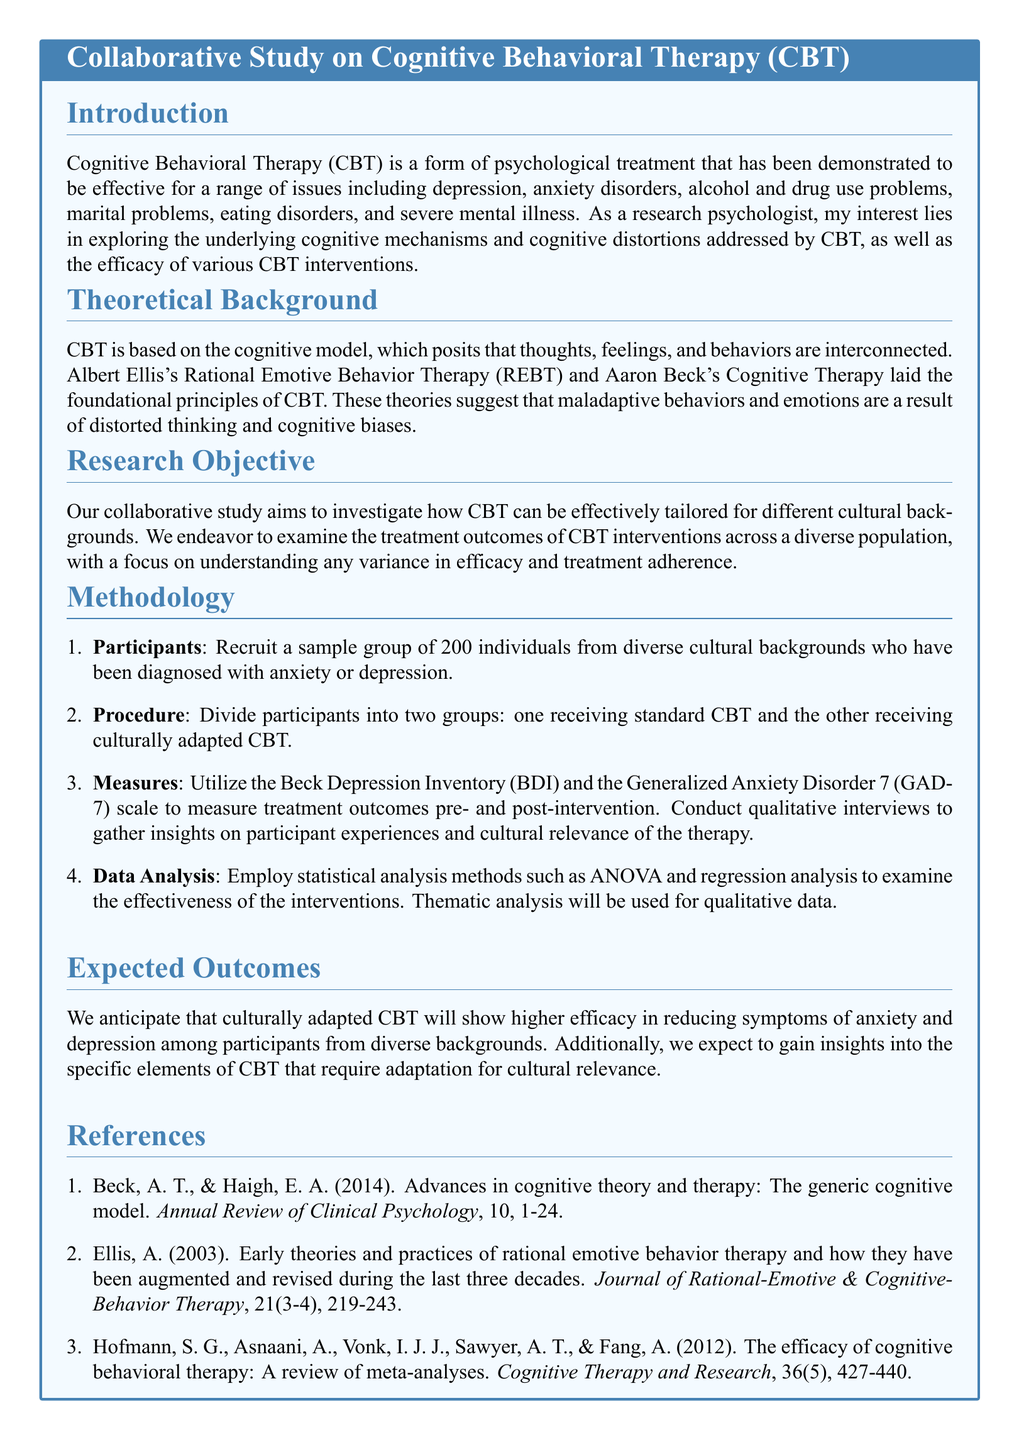What is CBT? CBT is defined in the introduction as a form of psychological treatment that is effective for various issues.
Answer: a form of psychological treatment Who developed Cognitive Therapy? The document mentions Aaron Beck as one of the developers of the foundational principles of CBT.
Answer: Aaron Beck What is the sample size for the study? The methodology section states that the sample group will consist of 200 individuals.
Answer: 200 individuals Which scale is used to measure treatment outcomes? The methodology specifies the use of the Beck Depression Inventory and the Generalized Anxiety Disorder 7 scale.
Answer: Beck Depression Inventory and GAD-7 scale What is the expected outcome of culturally adapted CBT? The document anticipates that culturally adapted CBT will show higher efficacy in reducing symptoms of anxiety and depression.
Answer: higher efficacy What analysis methods will be employed for data analysis? The methodology section outlines the use of statistical analysis methods such as ANOVA and regression analysis, along with thematic analysis for qualitative data.
Answer: ANOVA and regression analysis What is a primary focus of the research objective? The research objective primarily focuses on how CBT can be effectively tailored for different cultural backgrounds.
Answer: effectively tailored for different cultural backgrounds What kind of interviews will be conducted? The methodology indicates that qualitative interviews will be conducted to gather insights on participant experiences.
Answer: qualitative interviews 